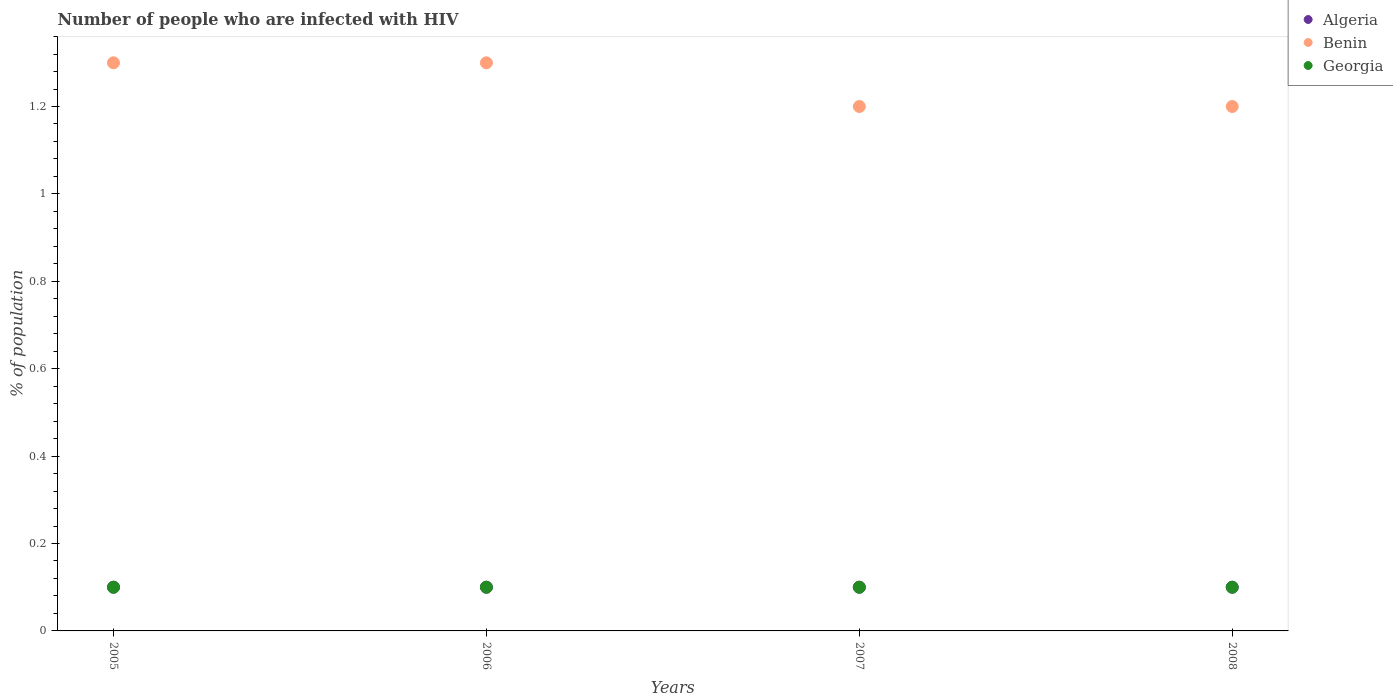How many different coloured dotlines are there?
Give a very brief answer. 3. What is the percentage of HIV infected population in in Benin in 2008?
Your answer should be very brief. 1.2. In which year was the percentage of HIV infected population in in Benin maximum?
Ensure brevity in your answer.  2005. What is the difference between the percentage of HIV infected population in in Benin in 2006 and the percentage of HIV infected population in in Algeria in 2007?
Offer a very short reply. 1.2. In the year 2005, what is the difference between the percentage of HIV infected population in in Benin and percentage of HIV infected population in in Georgia?
Your answer should be very brief. 1.2. What is the ratio of the percentage of HIV infected population in in Algeria in 2007 to that in 2008?
Offer a very short reply. 1. Is the difference between the percentage of HIV infected population in in Benin in 2005 and 2007 greater than the difference between the percentage of HIV infected population in in Georgia in 2005 and 2007?
Keep it short and to the point. Yes. What is the difference between the highest and the second highest percentage of HIV infected population in in Georgia?
Give a very brief answer. 0. What is the difference between the highest and the lowest percentage of HIV infected population in in Algeria?
Provide a succinct answer. 0. Is the sum of the percentage of HIV infected population in in Algeria in 2006 and 2008 greater than the maximum percentage of HIV infected population in in Georgia across all years?
Your response must be concise. Yes. Is the percentage of HIV infected population in in Benin strictly greater than the percentage of HIV infected population in in Algeria over the years?
Provide a short and direct response. Yes. What is the difference between two consecutive major ticks on the Y-axis?
Your response must be concise. 0.2. Are the values on the major ticks of Y-axis written in scientific E-notation?
Give a very brief answer. No. Does the graph contain grids?
Your answer should be very brief. No. Where does the legend appear in the graph?
Offer a terse response. Top right. How are the legend labels stacked?
Offer a very short reply. Vertical. What is the title of the graph?
Provide a short and direct response. Number of people who are infected with HIV. What is the label or title of the X-axis?
Give a very brief answer. Years. What is the label or title of the Y-axis?
Offer a very short reply. % of population. What is the % of population in Algeria in 2005?
Your response must be concise. 0.1. What is the % of population in Algeria in 2006?
Your answer should be compact. 0.1. What is the % of population of Benin in 2006?
Your answer should be compact. 1.3. What is the % of population in Georgia in 2006?
Make the answer very short. 0.1. What is the % of population of Algeria in 2007?
Your response must be concise. 0.1. What is the % of population of Algeria in 2008?
Keep it short and to the point. 0.1. Across all years, what is the maximum % of population of Algeria?
Your answer should be compact. 0.1. Across all years, what is the minimum % of population in Georgia?
Your response must be concise. 0.1. What is the total % of population in Benin in the graph?
Make the answer very short. 5. What is the difference between the % of population of Algeria in 2005 and that in 2006?
Your response must be concise. 0. What is the difference between the % of population in Benin in 2005 and that in 2006?
Keep it short and to the point. 0. What is the difference between the % of population in Georgia in 2005 and that in 2006?
Provide a succinct answer. 0. What is the difference between the % of population in Algeria in 2005 and that in 2007?
Provide a succinct answer. 0. What is the difference between the % of population of Benin in 2005 and that in 2007?
Keep it short and to the point. 0.1. What is the difference between the % of population in Georgia in 2005 and that in 2007?
Your response must be concise. 0. What is the difference between the % of population in Benin in 2005 and that in 2008?
Provide a short and direct response. 0.1. What is the difference between the % of population of Georgia in 2005 and that in 2008?
Your answer should be compact. 0. What is the difference between the % of population of Algeria in 2006 and that in 2007?
Give a very brief answer. 0. What is the difference between the % of population in Algeria in 2006 and that in 2008?
Your answer should be very brief. 0. What is the difference between the % of population in Benin in 2006 and that in 2008?
Your answer should be compact. 0.1. What is the difference between the % of population in Georgia in 2006 and that in 2008?
Provide a succinct answer. 0. What is the difference between the % of population in Algeria in 2007 and that in 2008?
Offer a terse response. 0. What is the difference between the % of population of Benin in 2007 and that in 2008?
Provide a succinct answer. 0. What is the difference between the % of population of Georgia in 2007 and that in 2008?
Your answer should be compact. 0. What is the difference between the % of population in Algeria in 2005 and the % of population in Georgia in 2006?
Keep it short and to the point. 0. What is the difference between the % of population of Algeria in 2005 and the % of population of Benin in 2007?
Provide a short and direct response. -1.1. What is the difference between the % of population of Benin in 2005 and the % of population of Georgia in 2008?
Ensure brevity in your answer.  1.2. What is the difference between the % of population of Algeria in 2006 and the % of population of Georgia in 2007?
Offer a very short reply. 0. What is the difference between the % of population in Benin in 2006 and the % of population in Georgia in 2007?
Your answer should be very brief. 1.2. What is the difference between the % of population in Algeria in 2006 and the % of population in Benin in 2008?
Provide a short and direct response. -1.1. What is the difference between the % of population in Algeria in 2007 and the % of population in Benin in 2008?
Your answer should be compact. -1.1. In the year 2005, what is the difference between the % of population in Algeria and % of population in Georgia?
Offer a very short reply. 0. In the year 2005, what is the difference between the % of population of Benin and % of population of Georgia?
Your answer should be very brief. 1.2. In the year 2007, what is the difference between the % of population in Algeria and % of population in Benin?
Offer a terse response. -1.1. In the year 2007, what is the difference between the % of population in Benin and % of population in Georgia?
Ensure brevity in your answer.  1.1. In the year 2008, what is the difference between the % of population of Algeria and % of population of Georgia?
Provide a short and direct response. 0. What is the ratio of the % of population of Algeria in 2005 to that in 2006?
Your answer should be very brief. 1. What is the ratio of the % of population in Algeria in 2005 to that in 2007?
Provide a short and direct response. 1. What is the ratio of the % of population in Georgia in 2005 to that in 2007?
Provide a succinct answer. 1. What is the ratio of the % of population of Algeria in 2005 to that in 2008?
Your response must be concise. 1. What is the ratio of the % of population of Georgia in 2005 to that in 2008?
Give a very brief answer. 1. What is the ratio of the % of population of Algeria in 2006 to that in 2007?
Provide a succinct answer. 1. What is the ratio of the % of population of Benin in 2006 to that in 2007?
Keep it short and to the point. 1.08. What is the ratio of the % of population in Algeria in 2006 to that in 2008?
Offer a terse response. 1. What is the ratio of the % of population in Georgia in 2007 to that in 2008?
Your response must be concise. 1. What is the difference between the highest and the lowest % of population in Algeria?
Your answer should be compact. 0. What is the difference between the highest and the lowest % of population of Benin?
Your answer should be compact. 0.1. 